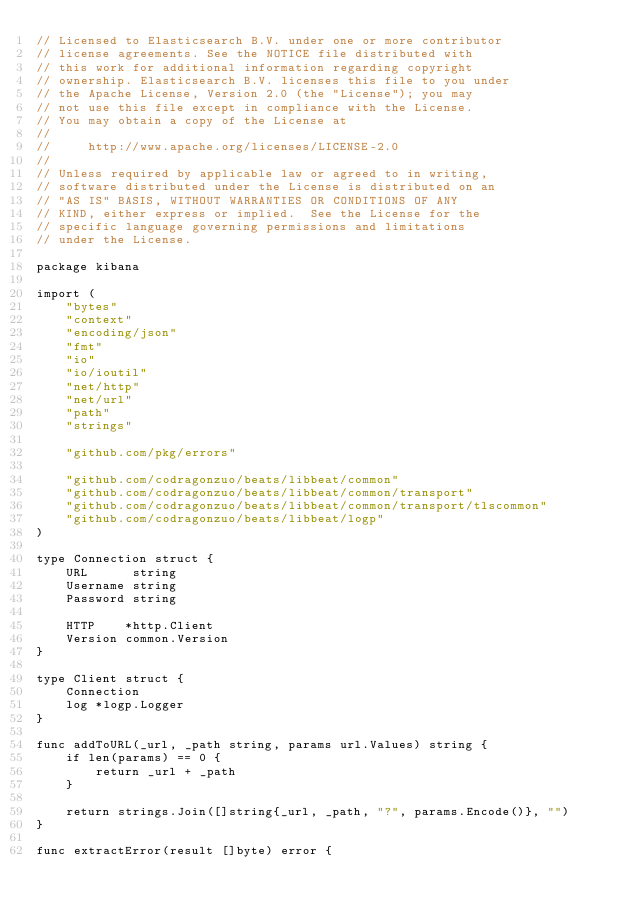<code> <loc_0><loc_0><loc_500><loc_500><_Go_>// Licensed to Elasticsearch B.V. under one or more contributor
// license agreements. See the NOTICE file distributed with
// this work for additional information regarding copyright
// ownership. Elasticsearch B.V. licenses this file to you under
// the Apache License, Version 2.0 (the "License"); you may
// not use this file except in compliance with the License.
// You may obtain a copy of the License at
//
//     http://www.apache.org/licenses/LICENSE-2.0
//
// Unless required by applicable law or agreed to in writing,
// software distributed under the License is distributed on an
// "AS IS" BASIS, WITHOUT WARRANTIES OR CONDITIONS OF ANY
// KIND, either express or implied.  See the License for the
// specific language governing permissions and limitations
// under the License.

package kibana

import (
	"bytes"
	"context"
	"encoding/json"
	"fmt"
	"io"
	"io/ioutil"
	"net/http"
	"net/url"
	"path"
	"strings"

	"github.com/pkg/errors"

	"github.com/codragonzuo/beats/libbeat/common"
	"github.com/codragonzuo/beats/libbeat/common/transport"
	"github.com/codragonzuo/beats/libbeat/common/transport/tlscommon"
	"github.com/codragonzuo/beats/libbeat/logp"
)

type Connection struct {
	URL      string
	Username string
	Password string

	HTTP    *http.Client
	Version common.Version
}

type Client struct {
	Connection
	log *logp.Logger
}

func addToURL(_url, _path string, params url.Values) string {
	if len(params) == 0 {
		return _url + _path
	}

	return strings.Join([]string{_url, _path, "?", params.Encode()}, "")
}

func extractError(result []byte) error {</code> 